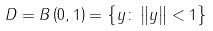Convert formula to latex. <formula><loc_0><loc_0><loc_500><loc_500>D = B \left ( 0 , 1 \right ) = \left \{ y \colon \left \| y \right \| < 1 \right \}</formula> 